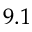<formula> <loc_0><loc_0><loc_500><loc_500>9 . 1</formula> 